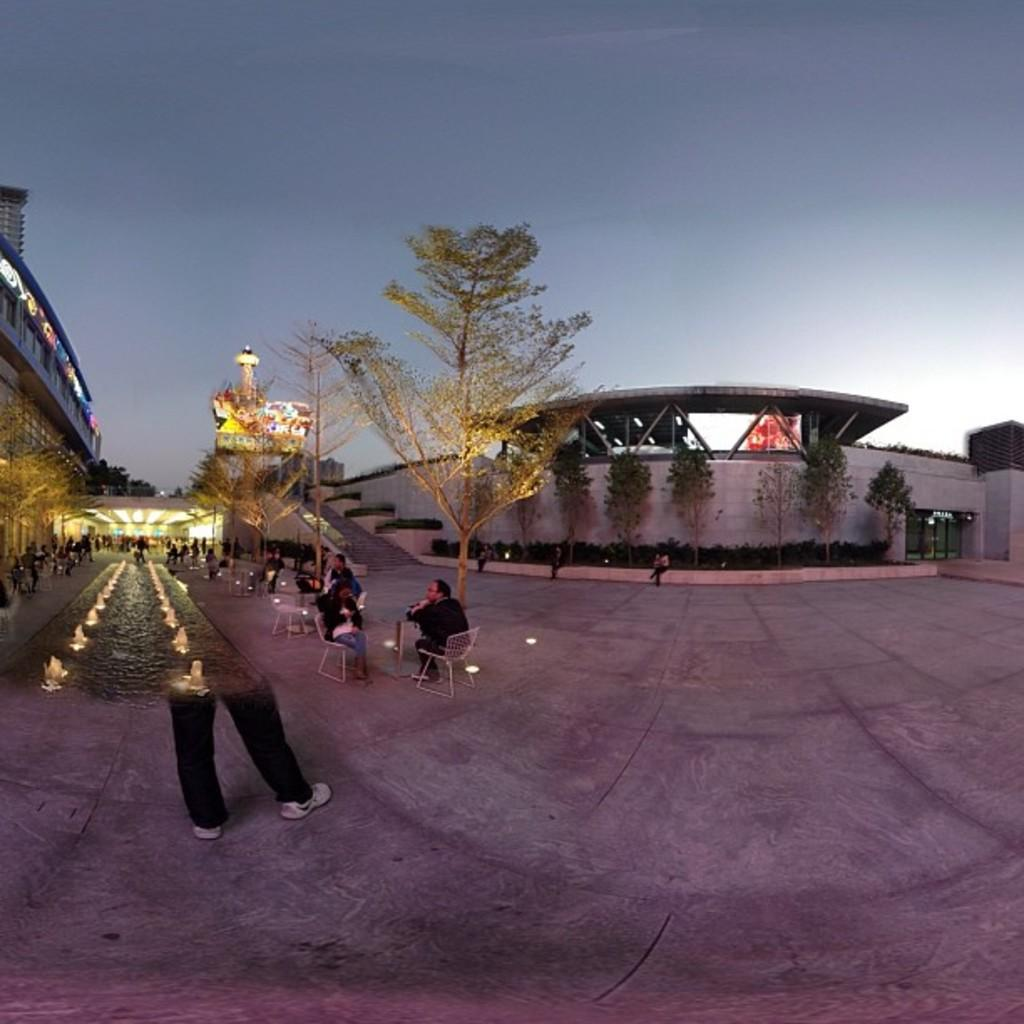What type of structures can be seen in the image? There are buildings in the image. What type of illumination is present in the image? Electric lights are present in the image. What type of signage can be seen in the image? Advertisement boards are visible in the image. What type of vegetation is present in the image? There are trees in the image. What type of seating is present in the image? Persons are sitting on chairs in the image. What type of water feature is present in the image? Fountains are present in the image. What part of the natural environment is visible in the image? The sky is visible in the image. What type of weather can be inferred from the image? Clouds are present in the sky, suggesting a partly cloudy day. How much payment is required to access the trail in the image? There is no trail present in the image, so no payment is required. What type of trouble are the persons sitting on chairs experiencing in the image? There is no indication of trouble in the image; the persons are simply sitting on chairs. 